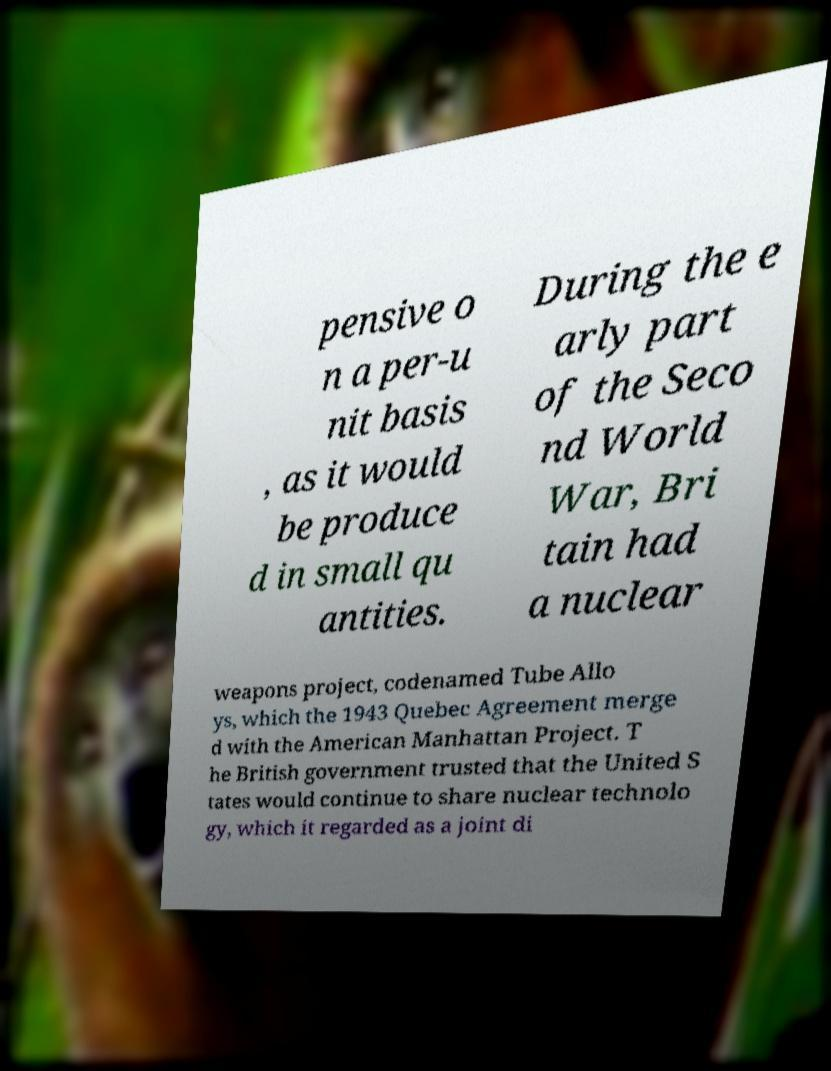Can you accurately transcribe the text from the provided image for me? pensive o n a per-u nit basis , as it would be produce d in small qu antities. During the e arly part of the Seco nd World War, Bri tain had a nuclear weapons project, codenamed Tube Allo ys, which the 1943 Quebec Agreement merge d with the American Manhattan Project. T he British government trusted that the United S tates would continue to share nuclear technolo gy, which it regarded as a joint di 